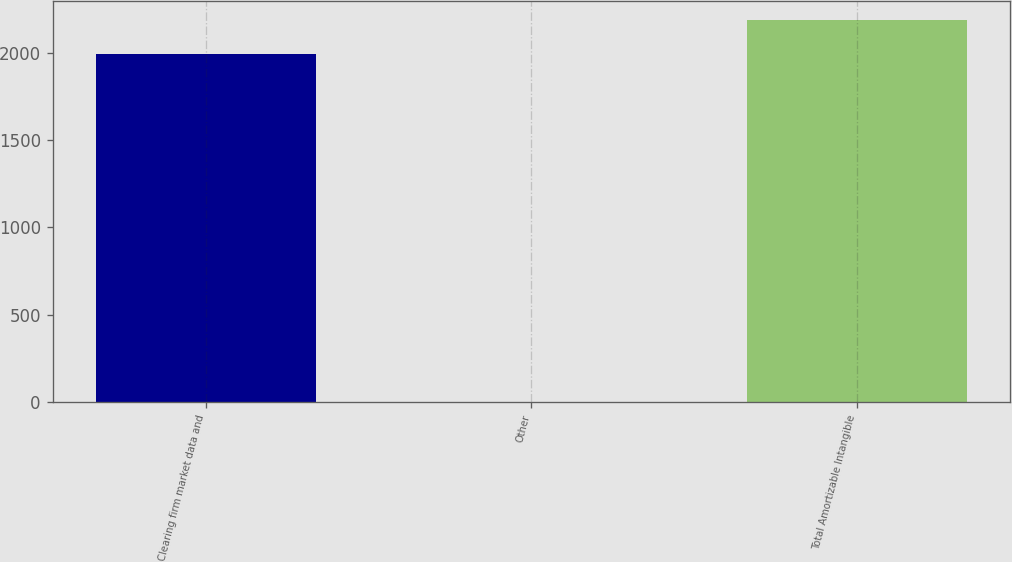Convert chart. <chart><loc_0><loc_0><loc_500><loc_500><bar_chart><fcel>Clearing firm market data and<fcel>Other<fcel>Total Amortizable Intangible<nl><fcel>1989.6<fcel>1.4<fcel>2188.64<nl></chart> 